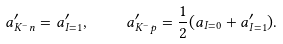Convert formula to latex. <formula><loc_0><loc_0><loc_500><loc_500>a ^ { \prime } _ { K ^ { - } n } = a ^ { \prime } _ { I = 1 } , \quad a ^ { \prime } _ { K ^ { - } p } = \frac { 1 } { 2 } ( a _ { I = 0 } + a ^ { \prime } _ { I = 1 } ) .</formula> 